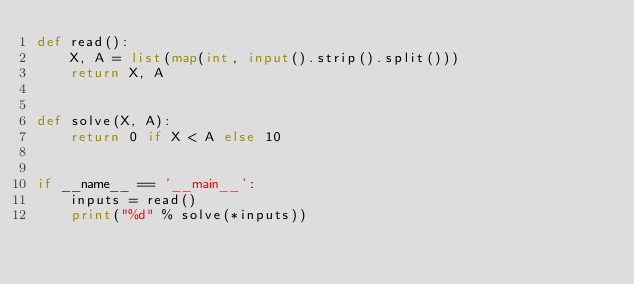Convert code to text. <code><loc_0><loc_0><loc_500><loc_500><_Python_>def read():
    X, A = list(map(int, input().strip().split()))
    return X, A


def solve(X, A):
    return 0 if X < A else 10


if __name__ == '__main__':
    inputs = read()
    print("%d" % solve(*inputs))</code> 